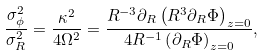Convert formula to latex. <formula><loc_0><loc_0><loc_500><loc_500>\frac { \sigma _ { \phi } ^ { 2 } } { \sigma _ { R } ^ { 2 } } = \frac { \kappa ^ { 2 } } { 4 \Omega ^ { 2 } } = \frac { R ^ { - 3 } \partial _ { R } \left ( R ^ { 3 } \partial _ { R } \Phi \right ) _ { z = 0 } } { 4 R ^ { - 1 } \left ( \partial _ { R } \Phi \right ) _ { z = 0 } } ,</formula> 